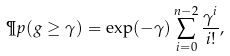Convert formula to latex. <formula><loc_0><loc_0><loc_500><loc_500>\P p ( g \geq \gamma ) = \exp ( - \gamma ) \sum _ { i = 0 } ^ { n - 2 } \frac { \gamma ^ { i } } { i ! } ,</formula> 